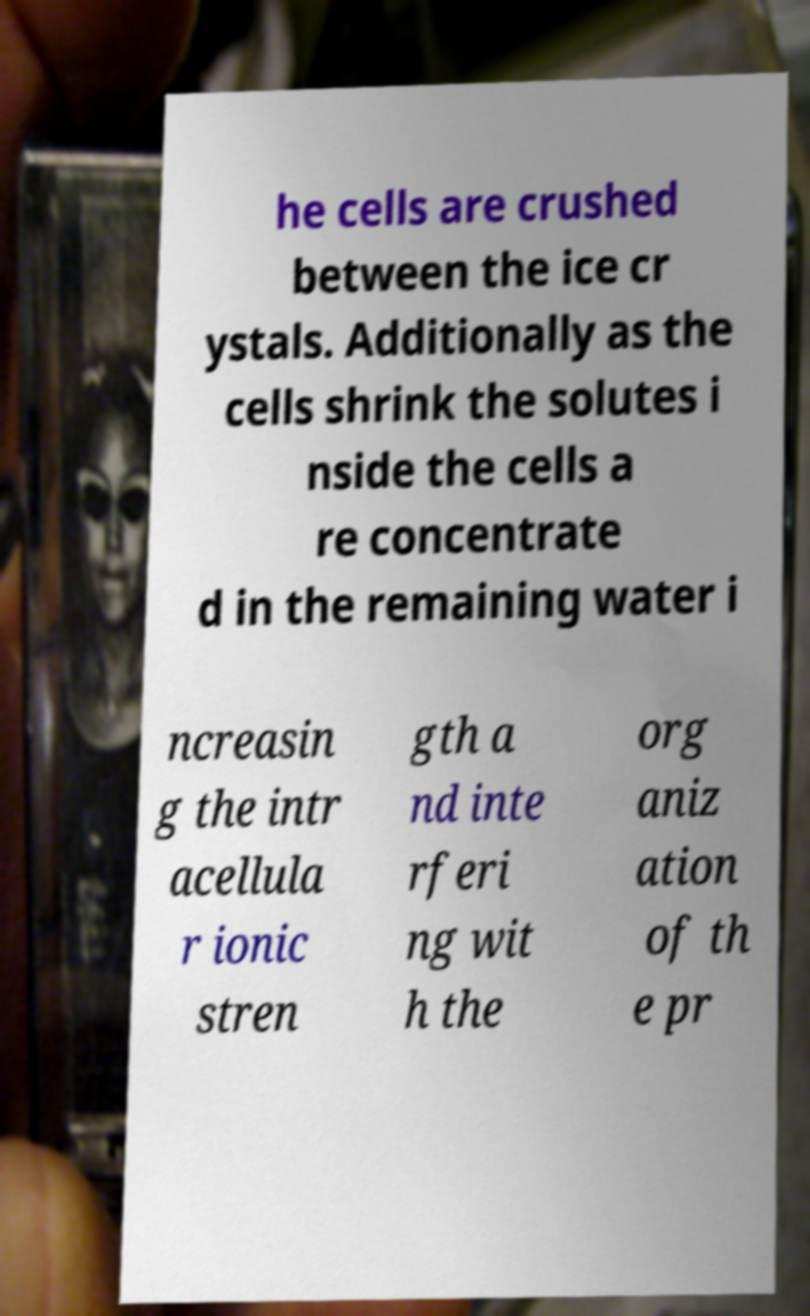Could you assist in decoding the text presented in this image and type it out clearly? he cells are crushed between the ice cr ystals. Additionally as the cells shrink the solutes i nside the cells a re concentrate d in the remaining water i ncreasin g the intr acellula r ionic stren gth a nd inte rferi ng wit h the org aniz ation of th e pr 